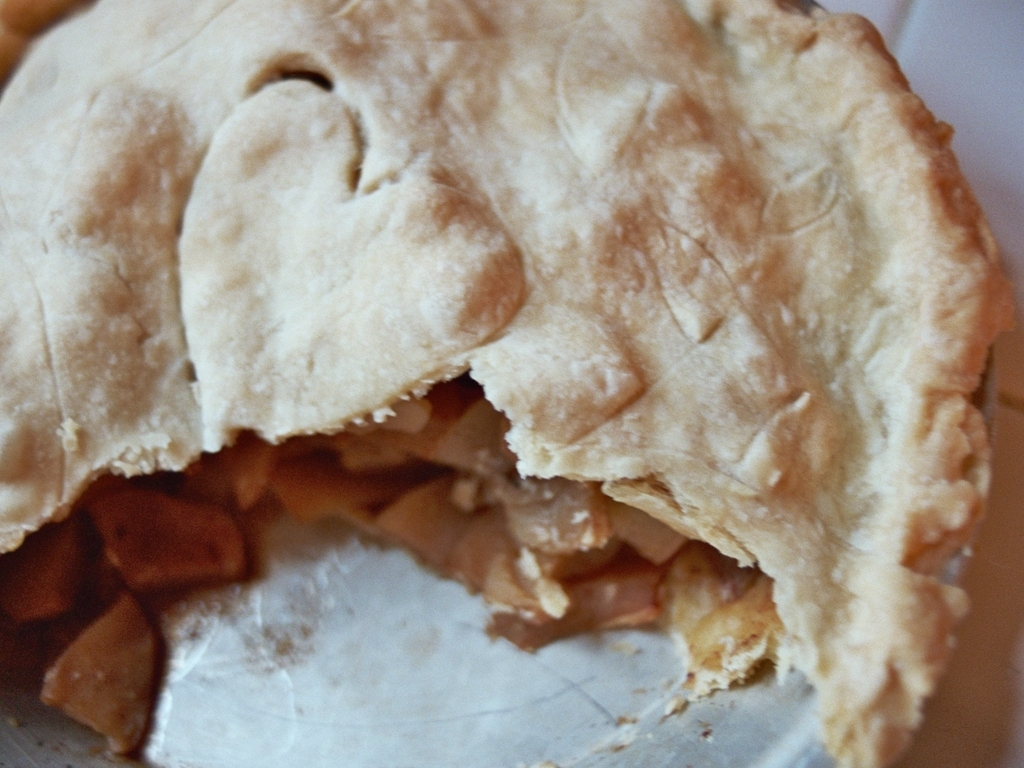Describe the texture and quality of the pie's crust. The crust of the pie appears flaky and golden brown, suggesting it has been baked to a desirable consistency. There are no signs of burning or undercooking, pointing towards a well-executed baking process. Can you infer anything about the setting or context in which this pie is served? Without additional context around the pie, it's hard to infer the setting. However, the simplicity of the presentation, without any accompaniments in the image, may imply a casual, homey environment rather than a formal setting. 